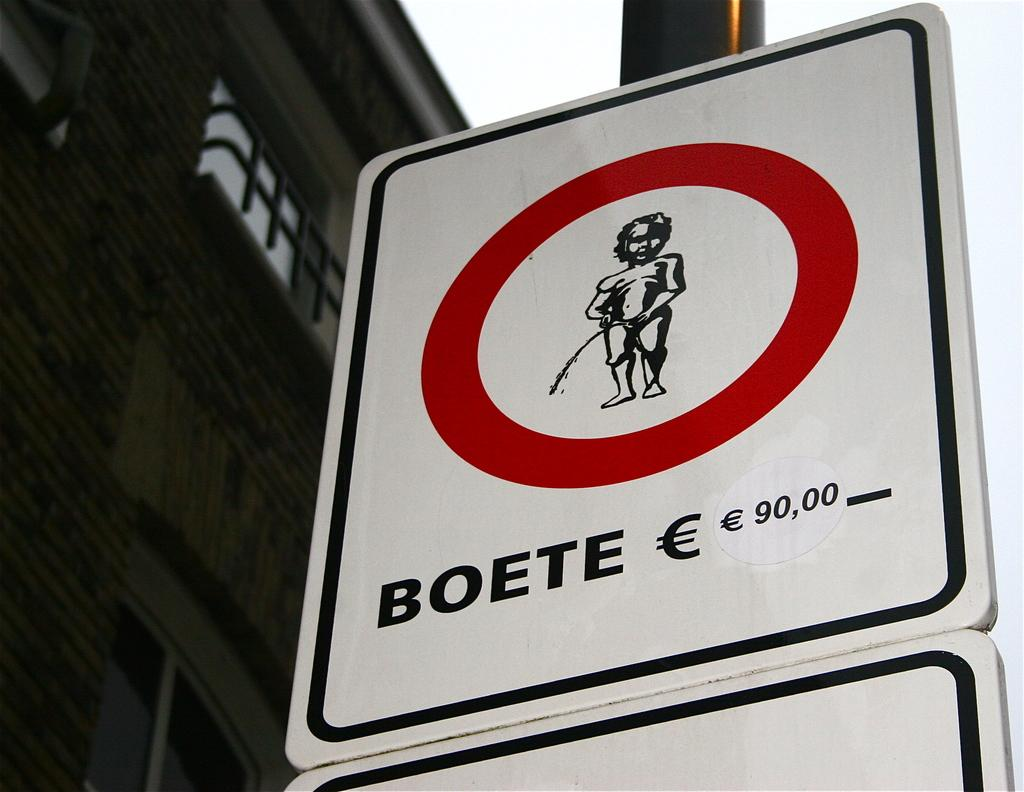<image>
Summarize the visual content of the image. a close up of a BOETE sign on a black pole 